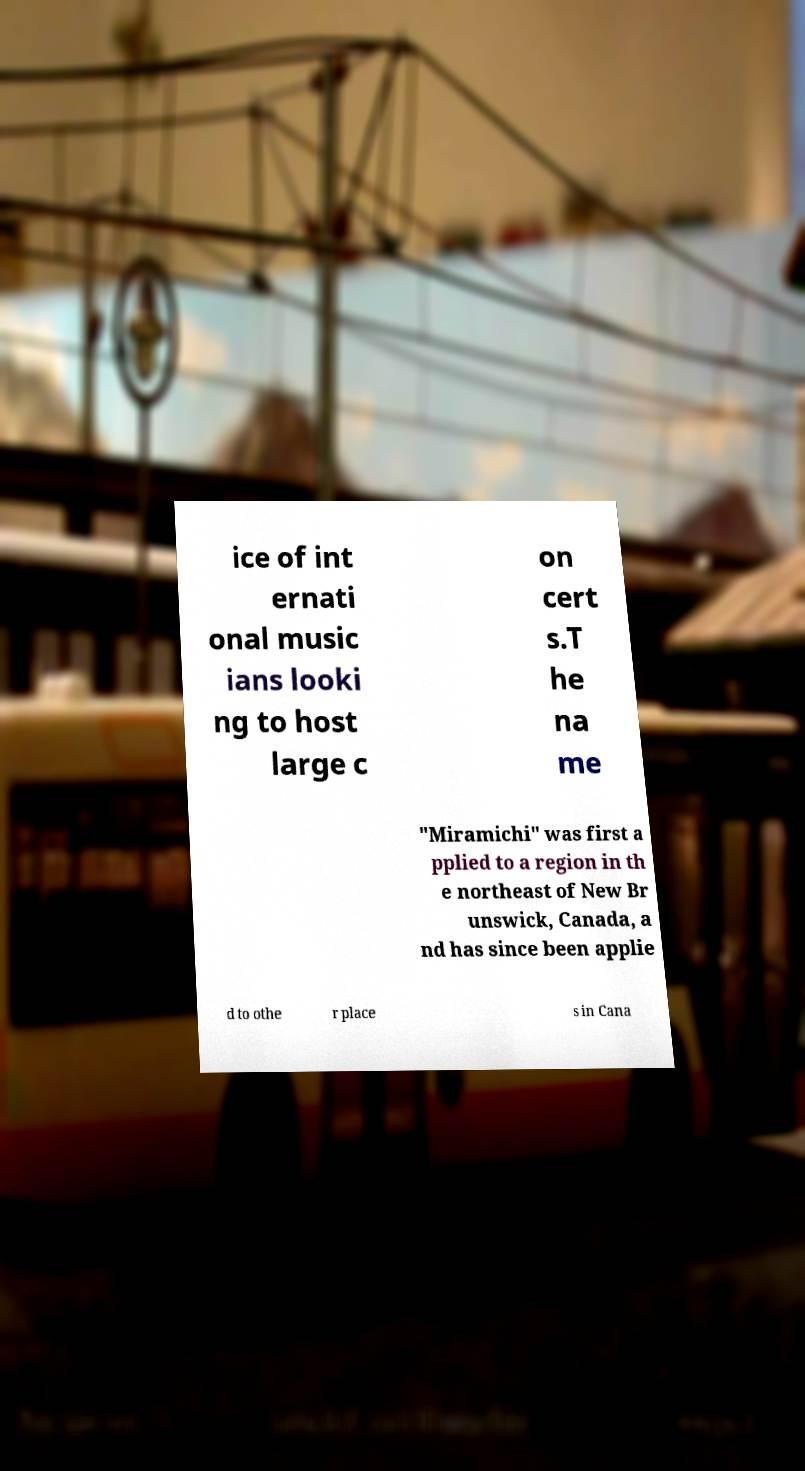Could you assist in decoding the text presented in this image and type it out clearly? ice of int ernati onal music ians looki ng to host large c on cert s.T he na me "Miramichi" was first a pplied to a region in th e northeast of New Br unswick, Canada, a nd has since been applie d to othe r place s in Cana 